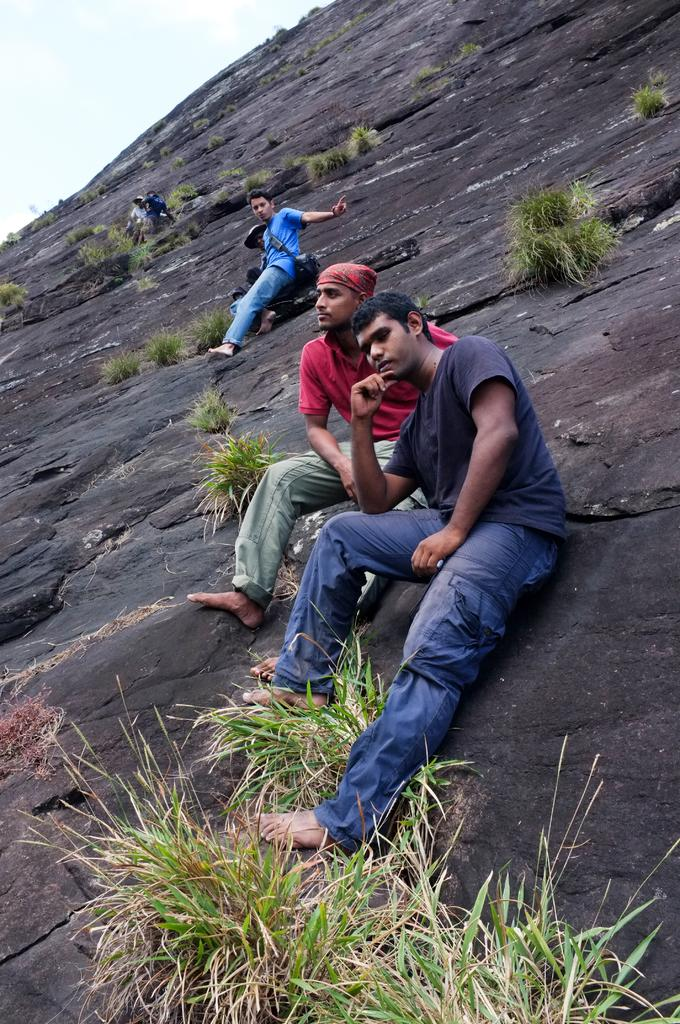What are the people in the image doing? The people in the image are sitting. What type of surface are the people sitting on? The grass is visible in the image, which suggests that the people may be sitting on the grass. What type of cheese is being used for educational purposes in the image? There is no cheese or educational activity present in the image. Is there a train visible in the image? There is no train present in the image. 